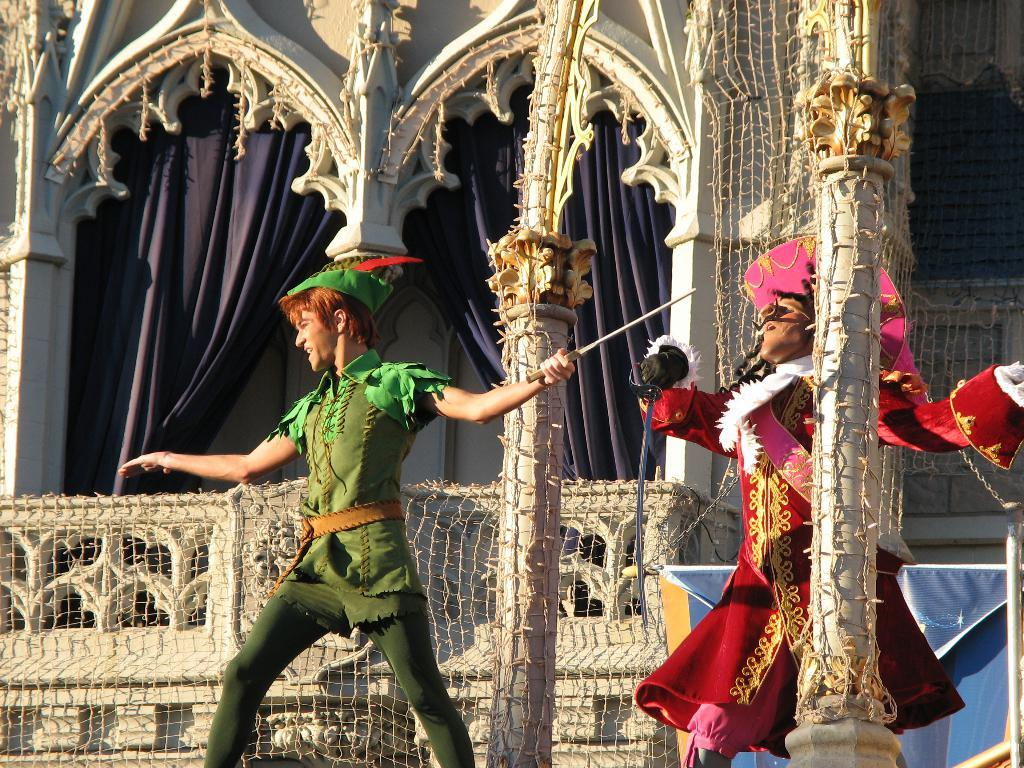How many people are in the image? There are two people in the image. What are the two people doing? The two people are dancing. What object are the two people holding? The two people are holding a knife. What can be seen in the background of the image? There is a building in the background of the image. What is covering the building? The building is covered with a net. What type of window treatment is present in the image? There are curtains in the image. What additional decoration is present in the image? There is a banner in the image. What type of corn is being harvested by the bee in the image? There is no corn or bee present in the image. 